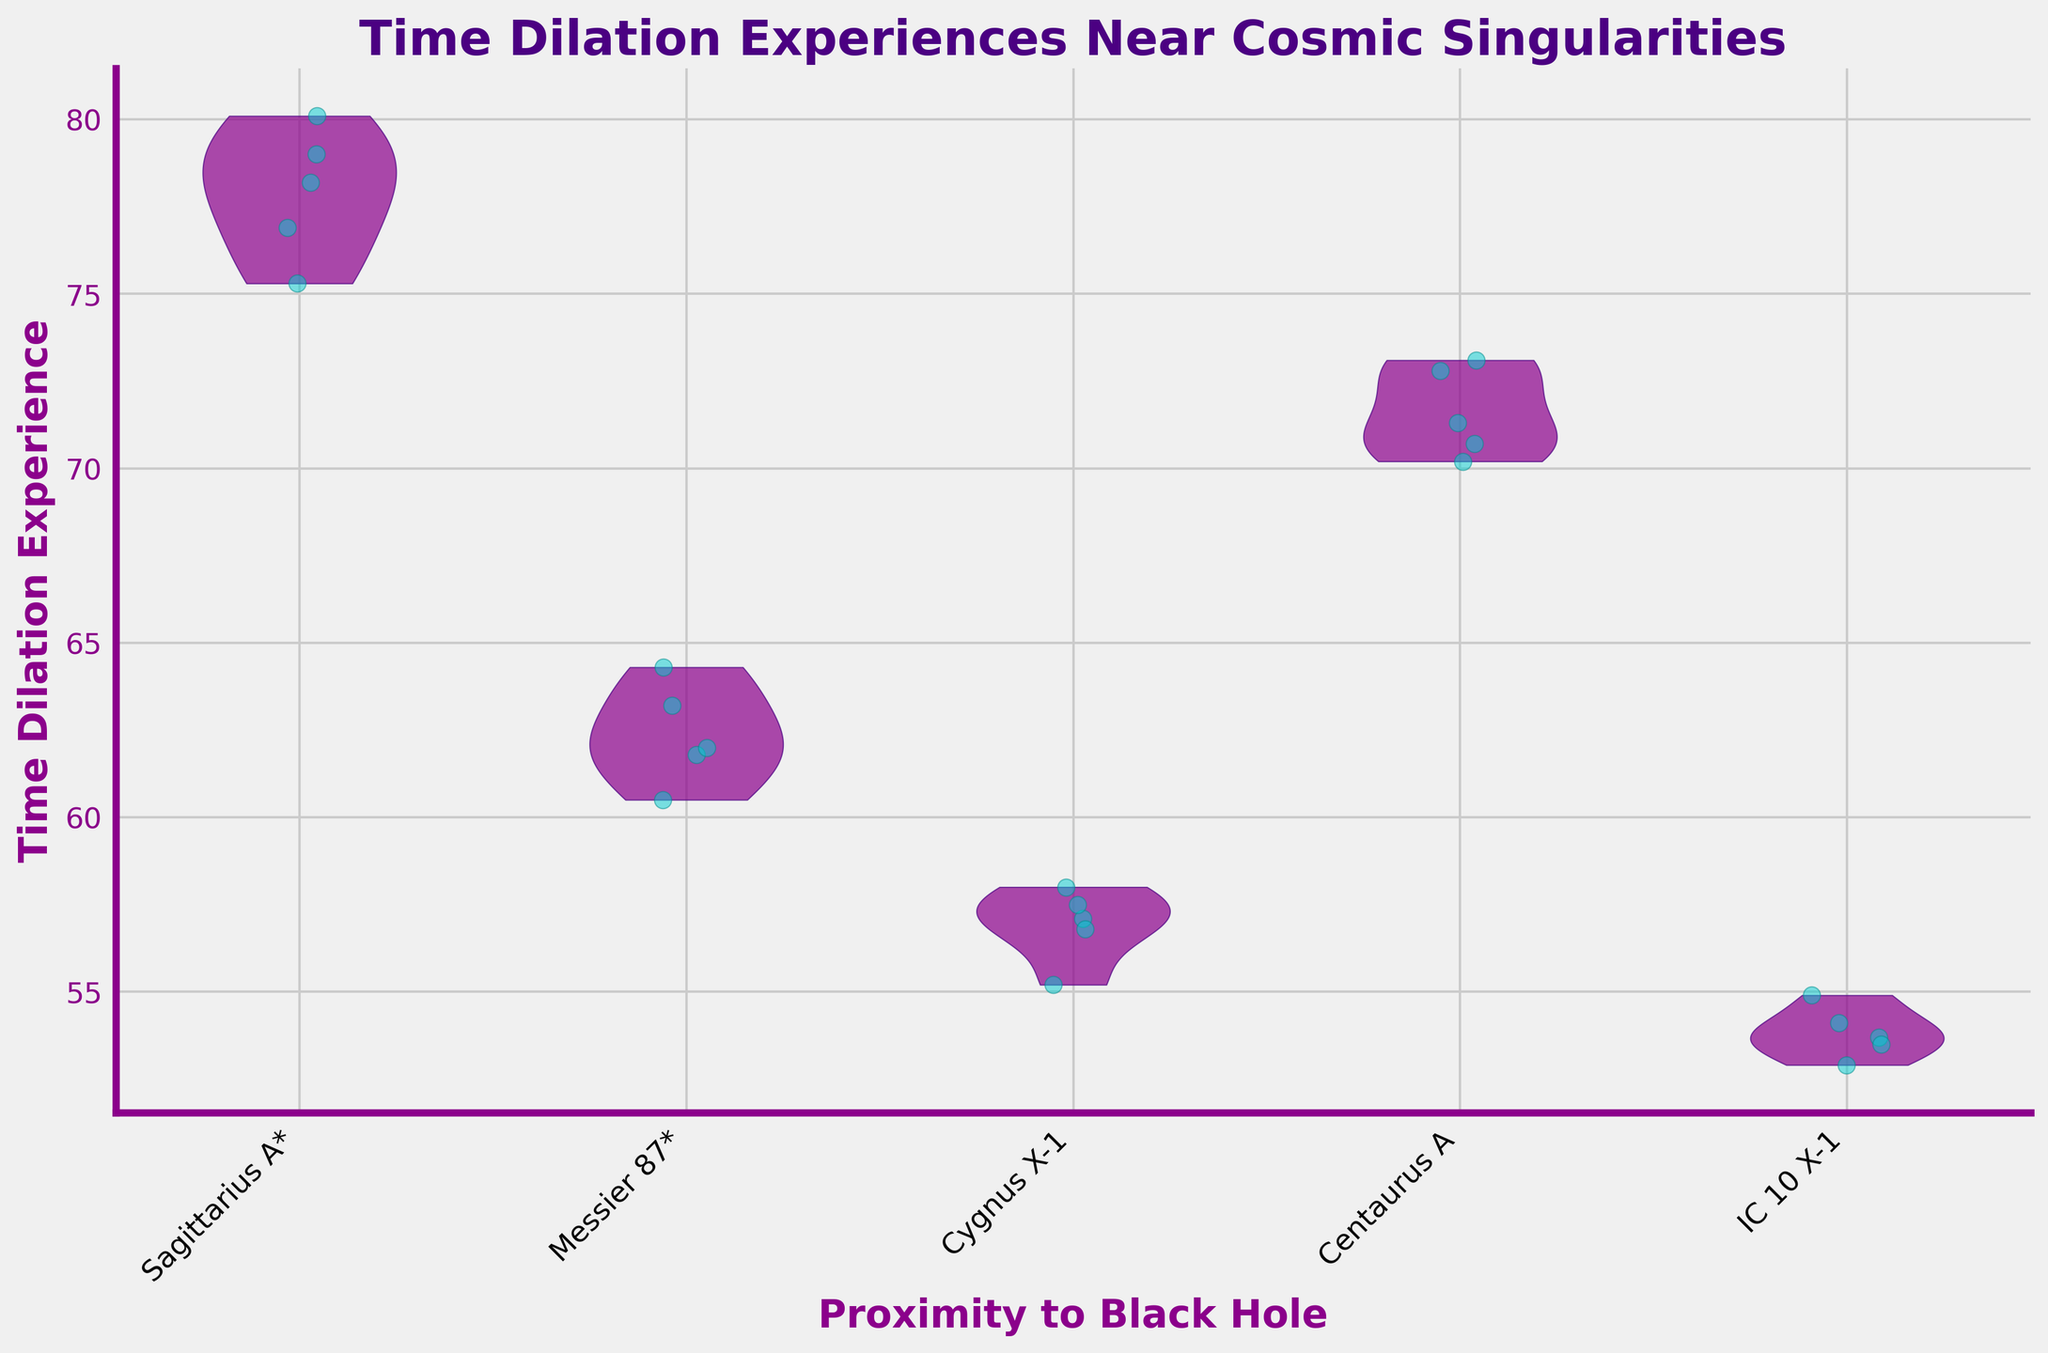What is the title of the figure? The title of the figure is usually displayed at the top in a larger font. In this case, it reads "Time Dilation Experiences Near Cosmic Singularities".
Answer: Time Dilation Experiences Near Cosmic Singularities How many data points are visualized for the black hole "Sagittarius A*"? To determine the number of data points for "Sagittarius A*", look at the jittered points within the violin plot corresponding to "Sagittarius A*". There are five points visible in this region.
Answer: 5 Which black hole shows the highest range of time dilation experiences? Observing all the violin plots, the one with the largest spread from the lowest to the highest point indicates the highest range. "Sagittarius A*" exhibits the widest range.
Answer: Sagittarius A* What is the average time dilation experience for "Messier 87*"? To calculate the average for "Messier 87*", sum up the five data points (60.5, 64.3, 61.8, 63.2, 62.0) and divide by 5. The sum is (60.5 + 64.3 + 61.8 + 63.2 + 62.0) = 311.8, so the average is 311.8 / 5 = 62.36.
Answer: 62.36 Which black hole has the lowest time dilation experience on average? Compute the average for each group: "Sagittarius A*" (75.9), "Messier 87*" (62.36), "Cygnus X-1" (56.92), "Centaurus A" (71.62), "IC 10 X-1" (53.82). "IC 10 X-1" has the lowest average.
Answer: IC 10 X-1 Are the time dilation experiences for "Centaurus A" generally higher than those for "Cygnus X-1"? By comparing the jittered points visually, the entire spread (from minimum to maximum) of "Centaurus A" is generally higher than that of "Cygnus X-1".
Answer: Yes Which black hole's violin plot has the smallest spread, indicating least variability in time dilation experiences? The smallest spread typically means the narrowest violin plot. Observing all plots, "IC 10 X-1" has the narrowest spread.
Answer: IC 10 X-1 What is one unique feature of the jittered points in the plot? The jittered points are randomly scattered around each group to prevent overlap and each point is colored in a distinct manner from the violin plots. In this case, they are colored in a teal (or similar) shade with cyan edges.
Answer: They are colored teal with cyan edges 